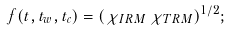Convert formula to latex. <formula><loc_0><loc_0><loc_500><loc_500>f ( t , t _ { w } , t _ { c } ) = ( \chi _ { I R M } \, \chi _ { T R M } ) ^ { 1 / 2 } ;</formula> 